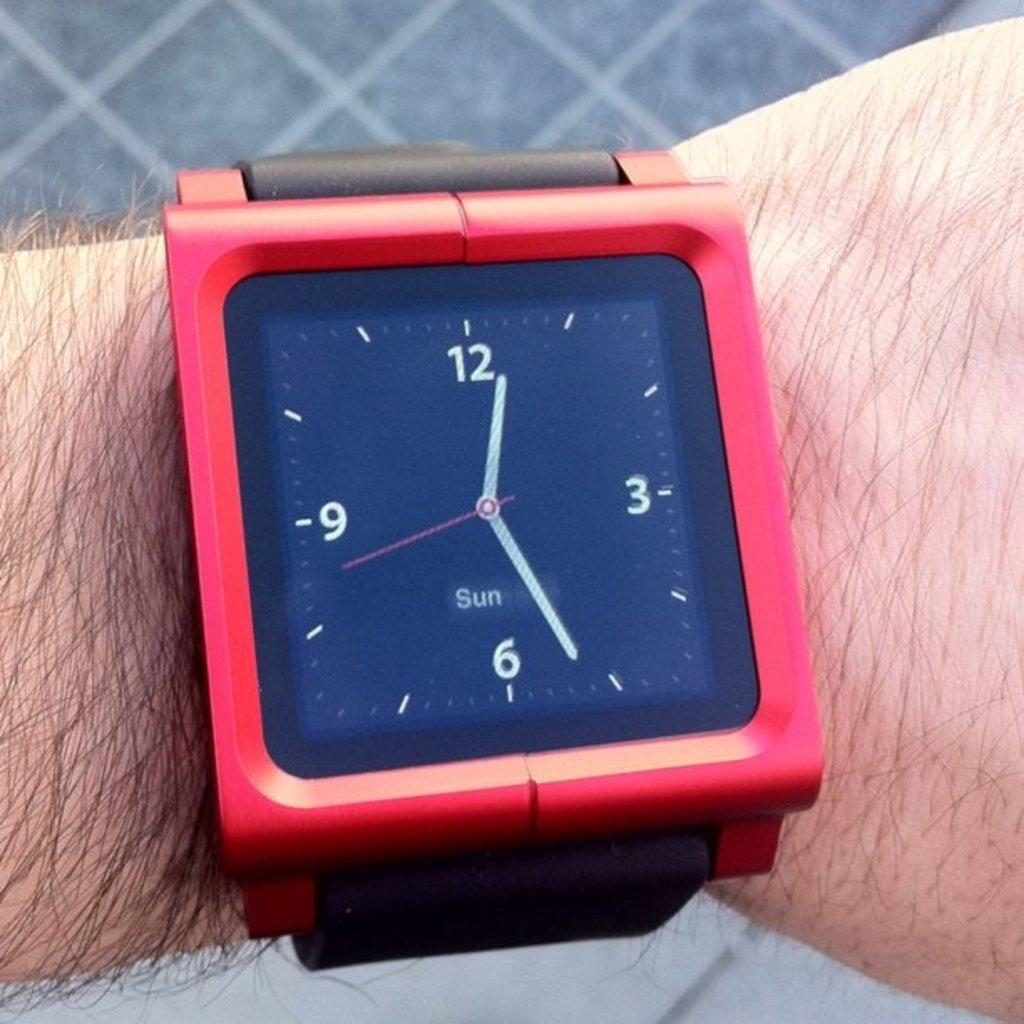<image>
Summarize the visual content of the image. A Sun brand red wristwatch is on a man's wrist. 